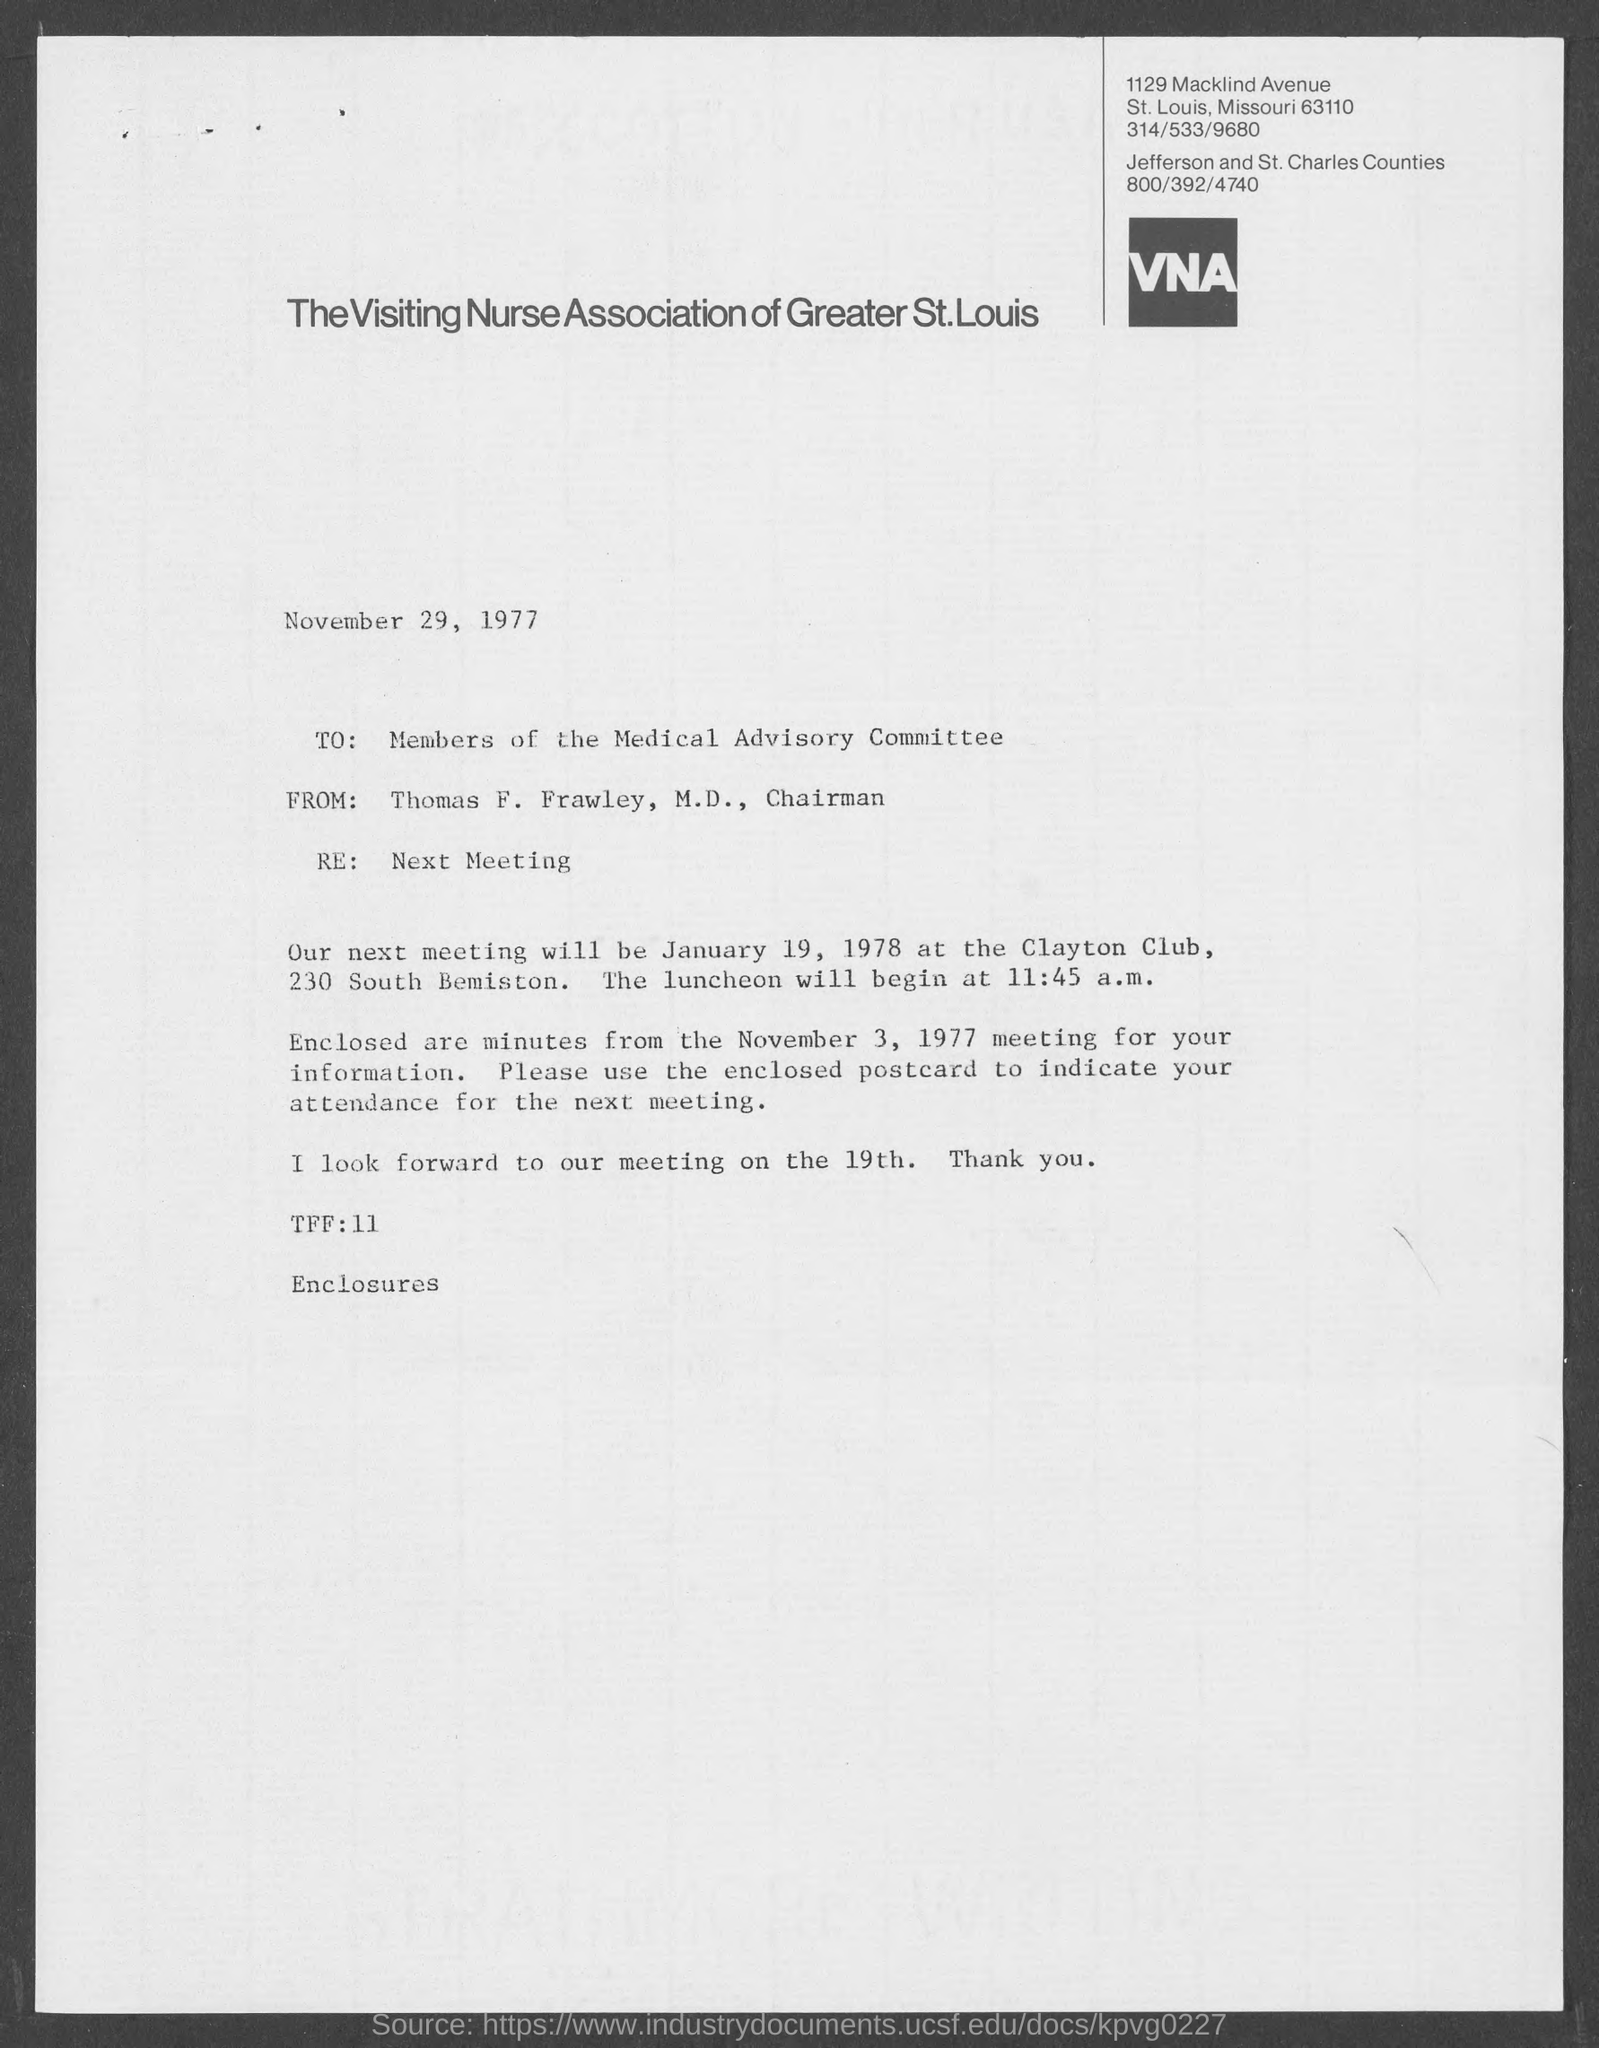What is the contact number of the visiting nurse association of greater st. louis, st. louis county ?
Make the answer very short. 314/533/9680. When is the memorandum dated?
Make the answer very short. November 29, 1977. What is the position of thomas f. frawley, m.d.,?
Your response must be concise. Chairman. When is the next meeting scheduled ?
Ensure brevity in your answer.  January 19, 1978. 